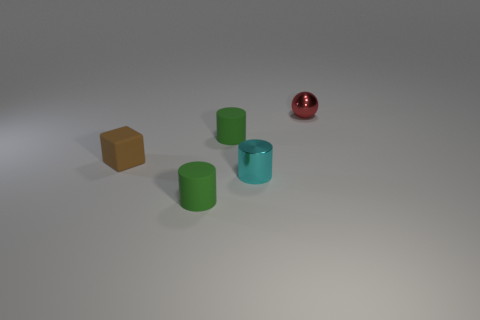Are there the same number of brown things that are in front of the red metal thing and tiny matte things?
Offer a very short reply. No. What color is the shiny thing that is right of the cyan thing?
Offer a terse response. Red. What number of other things are there of the same color as the metallic ball?
Your response must be concise. 0. Is there any other thing that is the same size as the brown block?
Provide a succinct answer. Yes. Do the green rubber object that is in front of the cyan cylinder and the small cyan shiny cylinder have the same size?
Your answer should be compact. Yes. What is the material of the small thing that is in front of the cyan cylinder?
Your answer should be very brief. Rubber. Is there any other thing that is the same shape as the tiny cyan object?
Provide a short and direct response. Yes. What number of metal things are red things or brown things?
Your answer should be very brief. 1. Is the number of cyan shiny cylinders behind the cyan cylinder less than the number of small metal balls?
Your response must be concise. Yes. What shape is the green object behind the small green rubber cylinder on the left side of the tiny cylinder that is behind the brown block?
Ensure brevity in your answer.  Cylinder. 